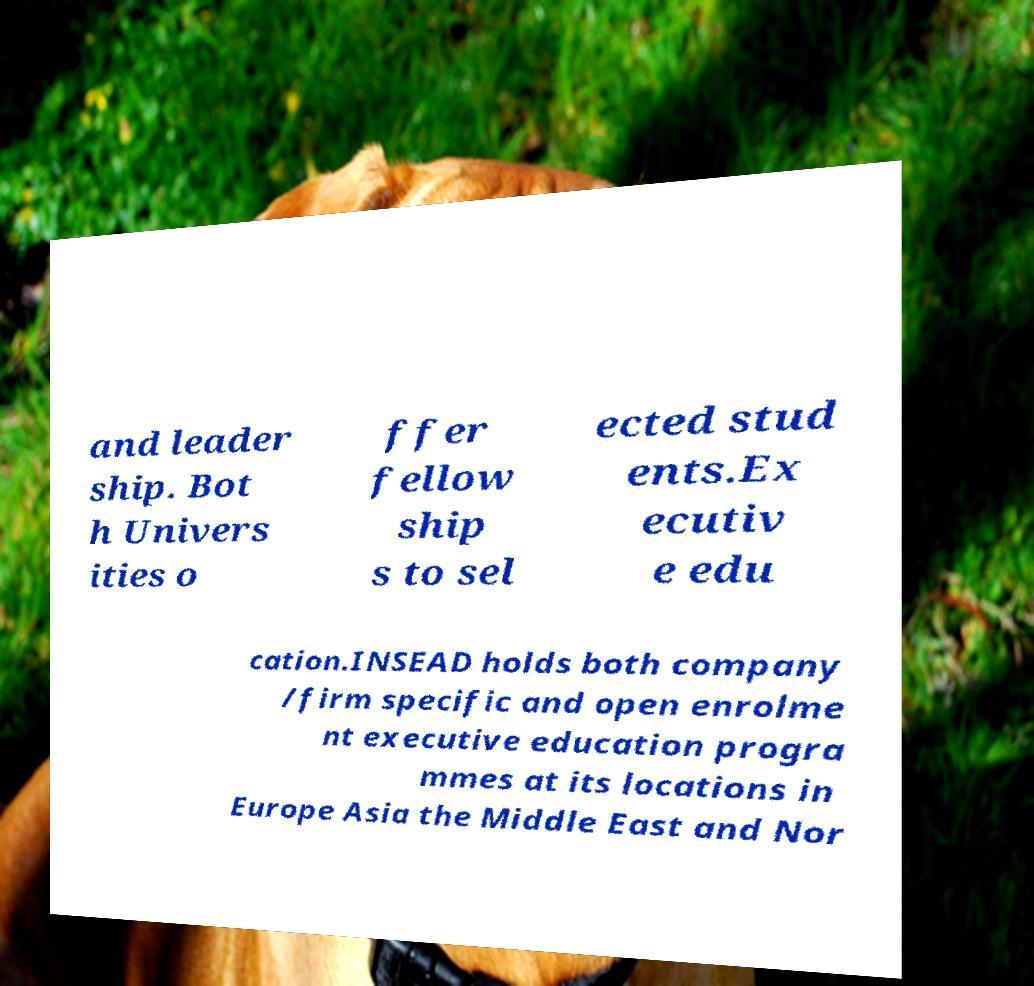For documentation purposes, I need the text within this image transcribed. Could you provide that? and leader ship. Bot h Univers ities o ffer fellow ship s to sel ected stud ents.Ex ecutiv e edu cation.INSEAD holds both company /firm specific and open enrolme nt executive education progra mmes at its locations in Europe Asia the Middle East and Nor 